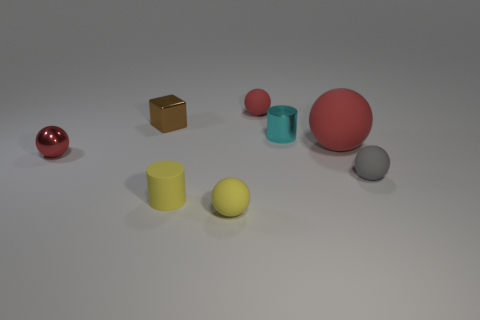What is the shape of the small rubber object that is the same color as the big object?
Your answer should be compact. Sphere. What shape is the red object that is both in front of the cyan cylinder and on the right side of the red shiny sphere?
Provide a succinct answer. Sphere. Is there a tiny ball?
Offer a terse response. Yes. There is a small yellow thing that is the same shape as the large red rubber object; what material is it?
Ensure brevity in your answer.  Rubber. The red matte thing that is behind the big red matte sphere that is in front of the small red object behind the big red matte object is what shape?
Give a very brief answer. Sphere. There is another tiny ball that is the same color as the shiny ball; what is it made of?
Offer a very short reply. Rubber. What number of tiny red metal objects are the same shape as the big red object?
Your answer should be compact. 1. Does the matte cylinder right of the brown cube have the same color as the rubber sphere that is on the left side of the tiny red matte sphere?
Give a very brief answer. Yes. What is the material of the gray thing that is the same size as the brown cube?
Your answer should be very brief. Rubber. Are there any cyan objects of the same size as the brown object?
Your answer should be compact. Yes. 